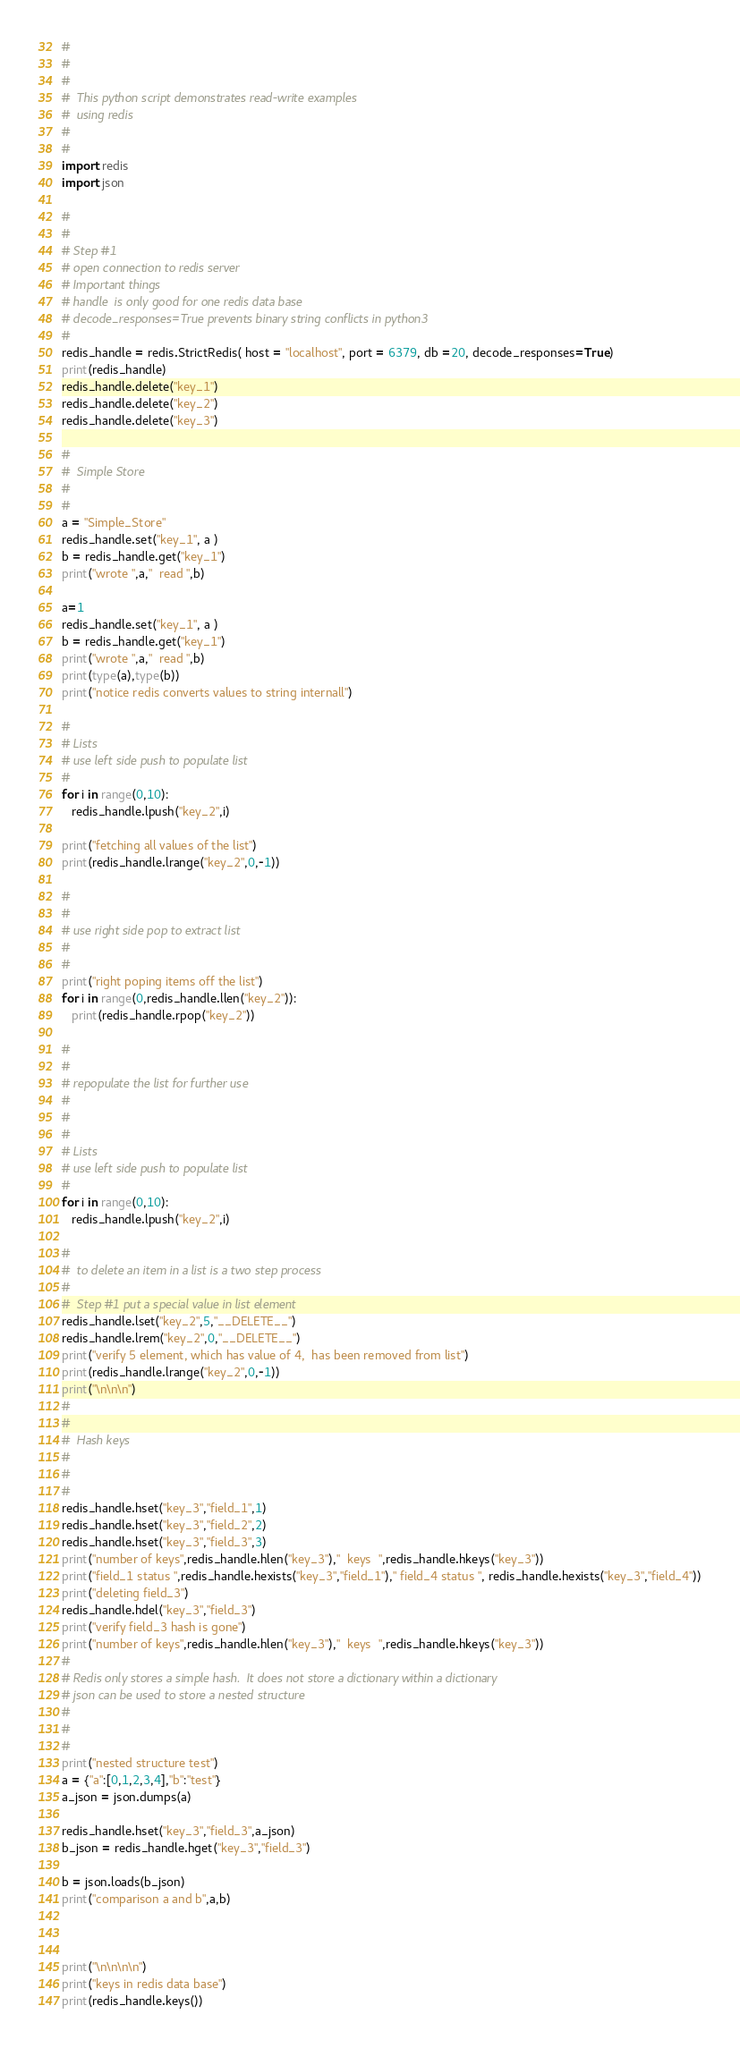<code> <loc_0><loc_0><loc_500><loc_500><_Python_>#
#
#
#  This python script demonstrates read-write examples
#  using redis
#
#
import redis
import json

#
#
# Step #1
# open connection to redis server
# Important things
# handle  is only good for one redis data base
# decode_responses=True prevents binary string conflicts in python3
#
redis_handle = redis.StrictRedis( host = "localhost", port = 6379, db =20, decode_responses=True)
print(redis_handle)
redis_handle.delete("key_1")
redis_handle.delete("key_2")
redis_handle.delete("key_3")

#
#  Simple Store
#
#
a = "Simple_Store"
redis_handle.set("key_1", a )
b = redis_handle.get("key_1")
print("wrote ",a,"  read ",b)

a=1
redis_handle.set("key_1", a )
b = redis_handle.get("key_1")
print("wrote ",a,"  read ",b)
print(type(a),type(b))
print("notice redis converts values to string internall")

#
# Lists
# use left side push to populate list
#
for i in range(0,10):
   redis_handle.lpush("key_2",i)

print("fetching all values of the list")   
print(redis_handle.lrange("key_2",0,-1))

#
#
# use right side pop to extract list
#
#
print("right poping items off the list")
for i in range(0,redis_handle.llen("key_2")):
   print(redis_handle.rpop("key_2"))
   
#
#
# repopulate the list for further use
#
#
#
# Lists
# use left side push to populate list
#
for i in range(0,10):
   redis_handle.lpush("key_2",i)
  
#
#  to delete an item in a list is a two step process
#
#  Step #1 put a special value in list element
redis_handle.lset("key_2",5,"__DELETE__")
redis_handle.lrem("key_2",0,"__DELETE__")
print("verify 5 element, which has value of 4,  has been removed from list")
print(redis_handle.lrange("key_2",0,-1))
print("\n\n\n")
#
#
#  Hash keys
#
#
#
redis_handle.hset("key_3","field_1",1)
redis_handle.hset("key_3","field_2",2)
redis_handle.hset("key_3","field_3",3)
print("number of keys",redis_handle.hlen("key_3"),"  keys  ",redis_handle.hkeys("key_3"))
print("field_1 status ",redis_handle.hexists("key_3","field_1")," field_4 status ", redis_handle.hexists("key_3","field_4"))
print("deleting field_3")
redis_handle.hdel("key_3","field_3")
print("verify field_3 hash is gone")
print("number of keys",redis_handle.hlen("key_3"),"  keys  ",redis_handle.hkeys("key_3"))
#
# Redis only stores a simple hash.  It does not store a dictionary within a dictionary
# json can be used to store a nested structure
#
#
#
print("nested structure test")
a = {"a":[0,1,2,3,4],"b":"test"}
a_json = json.dumps(a)

redis_handle.hset("key_3","field_3",a_json)
b_json = redis_handle.hget("key_3","field_3")

b = json.loads(b_json)
print("comparison a and b",a,b)



print("\n\n\n\n")
print("keys in redis data base")
print(redis_handle.keys())

</code> 